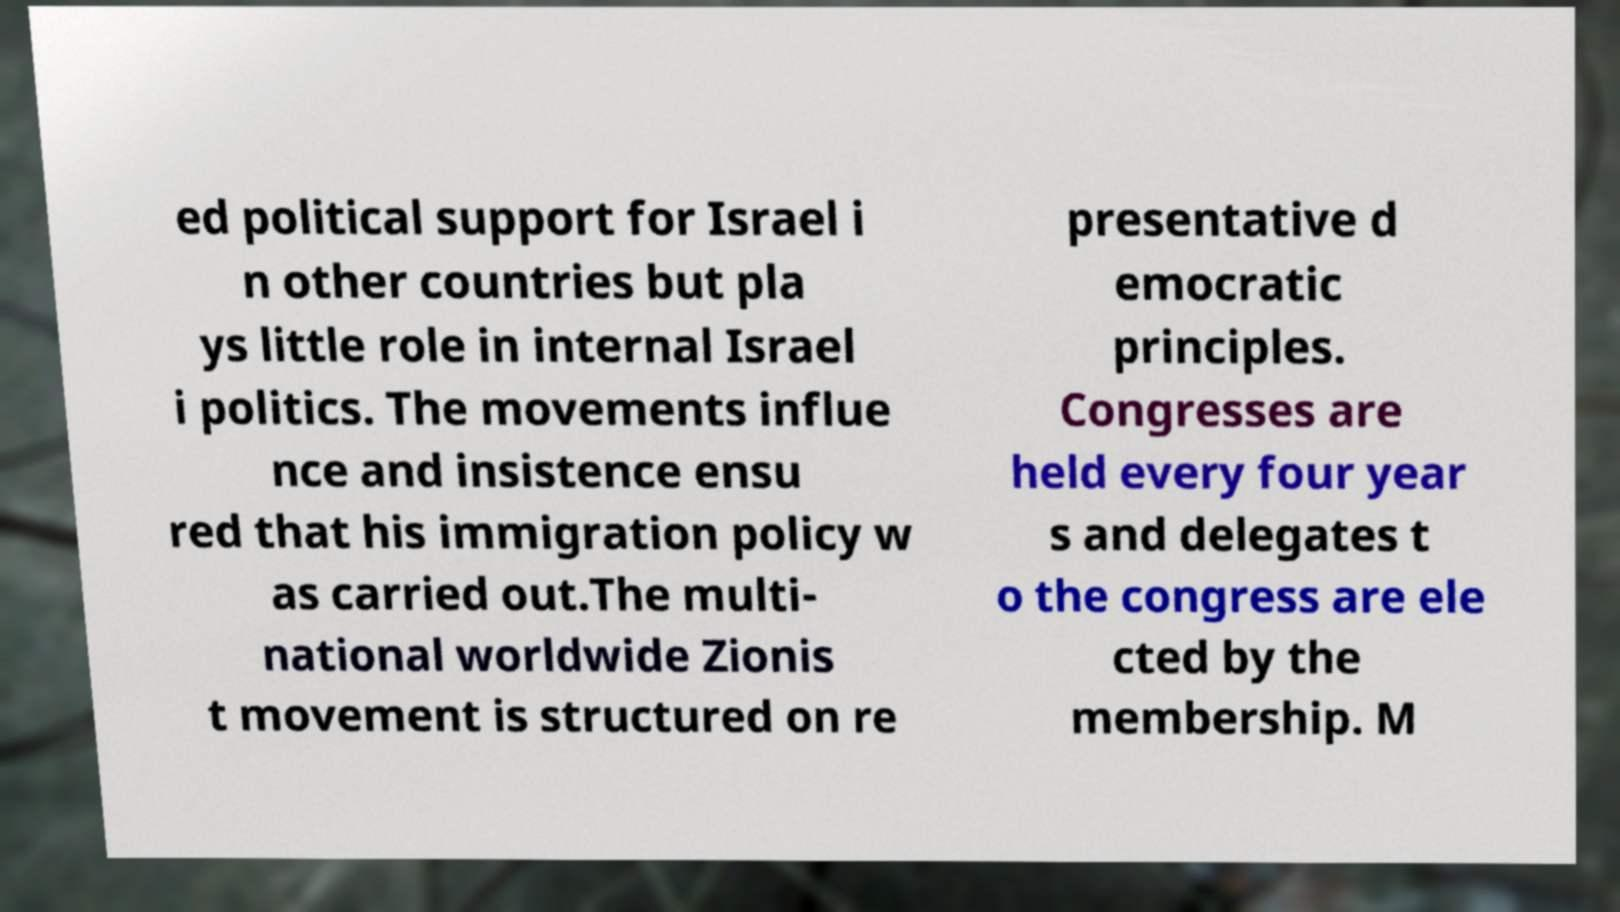Can you accurately transcribe the text from the provided image for me? ed political support for Israel i n other countries but pla ys little role in internal Israel i politics. The movements influe nce and insistence ensu red that his immigration policy w as carried out.The multi- national worldwide Zionis t movement is structured on re presentative d emocratic principles. Congresses are held every four year s and delegates t o the congress are ele cted by the membership. M 